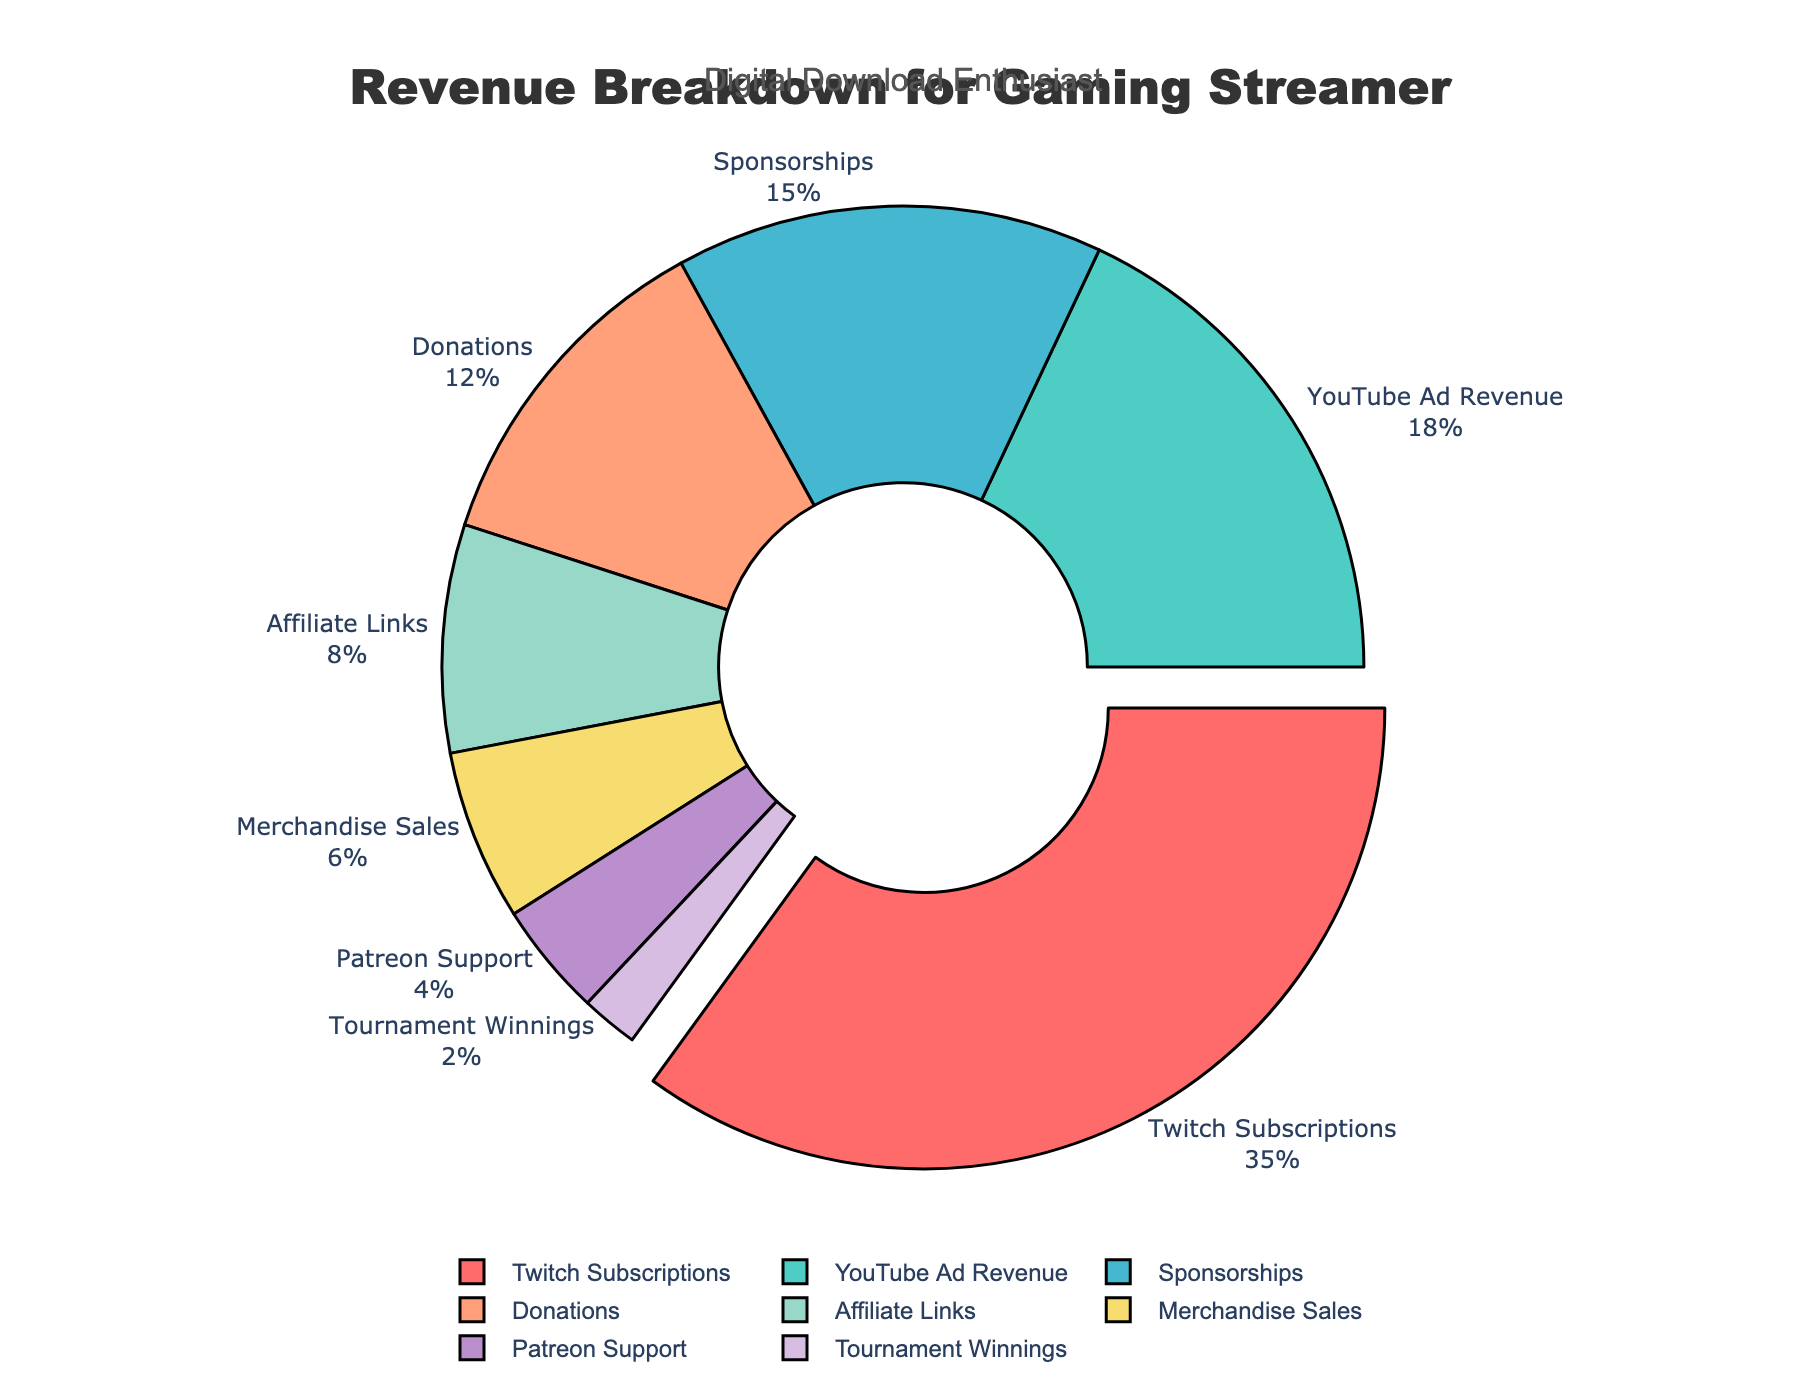What is the largest revenue source for the gaming streamer? To find the largest revenue source, look at the segment with the highest percentage value in the pie chart. The pie segment labeled "Twitch Subscriptions" has the largest proportion at 35%.
Answer: Twitch Subscriptions What is the difference in the percentage between YouTube Ad Revenue and Sponsorships? To find the difference, locate the percentages for YouTube Ad Revenue (18%) and Sponsorships (15%). Subtract the smaller percentage from the larger one: 18% - 15% = 3%.
Answer: 3% Which category has the smallest contribution to the revenue? Identify the segment with the smallest percentage in the pie chart. The segment labeled "Tournament Winnings" contributes 2%, the smallest among all sections.
Answer: Tournament Winnings What is the combined percentage of revenue from Donations and Affiliate Links? To get the combined percentage, add the percentages of Donations (12%) and Affiliate Links (8%): 12% + 8% = 20%.
Answer: 20% If the streamer wanted to double the revenue from Merchandise Sales, what would be its new percentage? Merchandise Sales currently contributes 6%. Doubling this value is calculated by multiplying 6% by 2: 6% * 2 = 12%.
Answer: 12% How many revenue sources contribute more than 10% each? Count the segments in the pie chart with percentages greater than 10%. These are Twitch Subscriptions (35%), YouTube Ad Revenue (18%), and Donations (12%): 3 revenue sources.
Answer: 3 What is the total revenue percentage from the top three sources combined? Add the percentages of the top three revenue sources: Twitch Subscriptions (35%), YouTube Ad Revenue (18%), and Sponsorships (15%). Summing these gives: 35% + 18% + 15% = 68%.
Answer: 68% Which revenue source section is pink in the pie chart? Look at the color of the sections. The pink-colored section corresponds to "Twitch Subscriptions" since it is usually the pulled out and highlighted section.
Answer: Twitch Subscriptions Compare the combined contribution of Patreon Support and Tournament Winnings to YouTube Ad Revenue. Which is greater? First, sum the percentages of Patreon Support (4%) and Tournament Winnings (2%): 4% + 2% = 6%. Compare this with YouTube Ad Revenue (18%). Since 18% > 6%, YouTube Ad Revenue is greater.
Answer: YouTube Ad Revenue Is the share of revenue from Affiliate Links greater than that from Merchandise Sales? Compare the percentages for Affiliate Links (8%) and Merchandise Sales (6%). Since 8% > 6%, affiliate links have a greater share.
Answer: Yes 